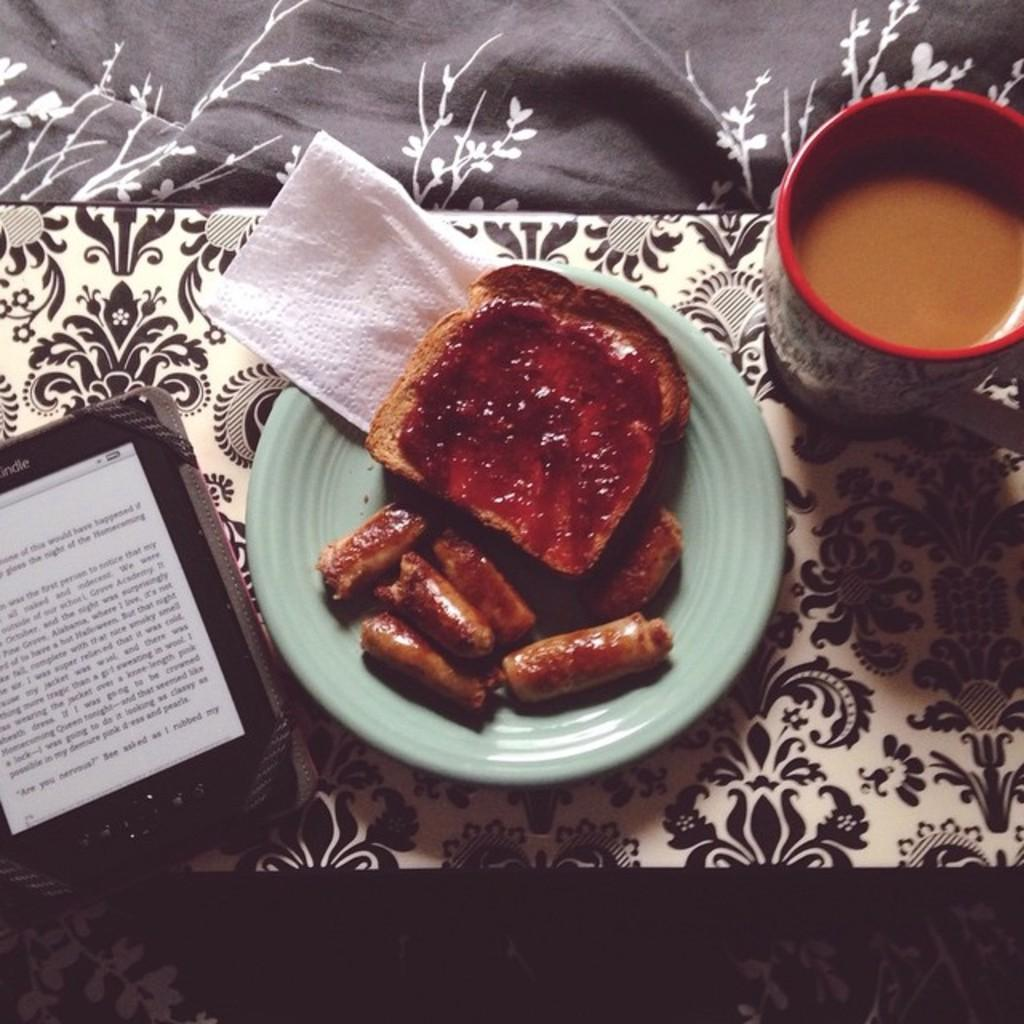<image>
Describe the image concisely. a tablet on the table next to dishes that says 'kindle' on the top of it 